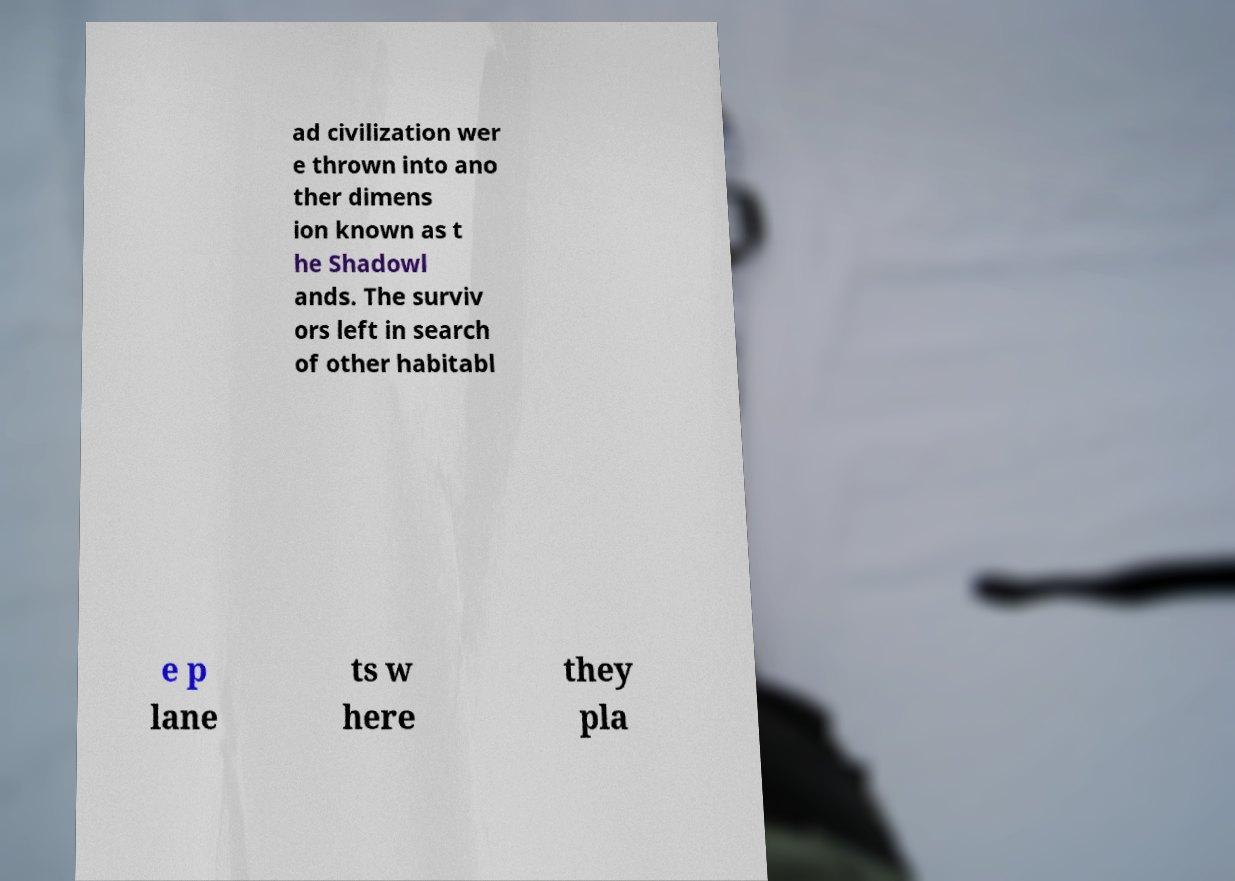For documentation purposes, I need the text within this image transcribed. Could you provide that? ad civilization wer e thrown into ano ther dimens ion known as t he Shadowl ands. The surviv ors left in search of other habitabl e p lane ts w here they pla 